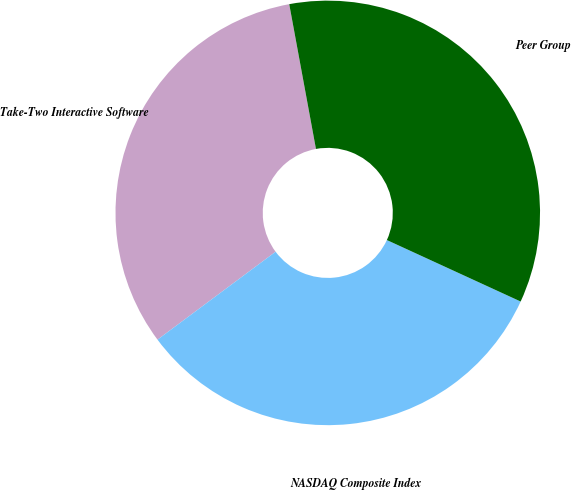<chart> <loc_0><loc_0><loc_500><loc_500><pie_chart><fcel>Take-Two Interactive Software<fcel>NASDAQ Composite Index<fcel>Peer Group<nl><fcel>32.28%<fcel>32.96%<fcel>34.76%<nl></chart> 